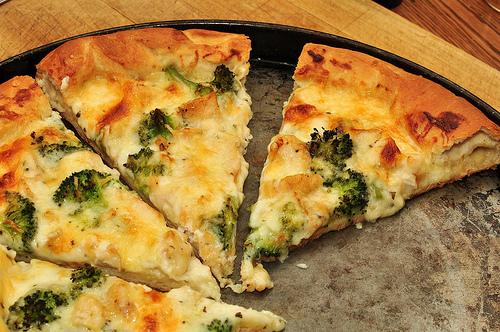Identify the material of the table and its color. The table is made of wood and is brown in color. Count the number of broccoli toppings on the pizza slices. There are 12 broccoli toppings on the pizza slices. What kind of topping can be seen on the pizza slices? Green broccoli can be seen as a topping on the pizza slices. How many pieces of pizza are there in the image and where are they placed? There are four pieces of pizza placed on a plate. Briefly describe the arrangement of objects in the image. A pizza with broccoli toppings is on a plate, the tray is on a wooden board on a brown wooden table, and there are some slices separated on a pan. What is the shape of the empty space between the pizzas? The space in between the pizzas is rectangular. What is the color of the cheese on the pizza? The cheese on the pizza is white in color. Describe the interaction between the wooden board and the tray. The tray is placed on the wooden board. Mention two colors you can see for different objects in the image. Green for the broccoli and brown for the table. What is the main food item in the image and its shape? The main food item is pizza, which has triangle-shaped slices. Can you describe the arrangement of the pizza pieces in the plate? There are four pizza pieces arranged in a circle on the plate. How many broccoli toppings are on the pizza slices? There are various numbers of broccoli toppings on the pizza slices. How would you describe the space between the pizzas? There is a considerable empty space between the pizzas. Create a short story based on the image. Once upon a time, in a small Italian restaurant, a unique broccoli pizza was created. Four triangular slices of perfection, with a golden crust, and white cheese melting among the vibrant green broccoli. It was served on a grey tray that lay on a rustic wooden board, over the brown wooden table. This pizza became the talk of the town, as everyone wanted a taste of the delightful and unexpected combination. What is the crust's position on the pizza slices, and where is the edge of the crust located? The crust is on the outer part of the pizza slices, and the edge of the crust is at the wider end of the triangles. Is the wooden board on the table blue in color? This instruction is misleading because it says the wooden board is blue, whereas the image information describes the board as brown. Can you see a circular-shaped pizza slice? This instruction is misleading because the image information states that the pizza slices are triangle in shape, not circular. Is the broccoli on the pizza red in color? The instruction is misleading because the image information mentions that the broccoli is green in color, not red. Explain the layout of the objects in the image. A pizza with broccoli toppings is on a grey tray on a wooden board on a brown table. There are also slices of pizza on pans and a bread nearby. Is the table made of glass? This instruction is misleading because the image information states that the table is made of brown wood. How many pieces of pizza are on the table, and what is underneath the pizza? There are two pieces of pizza on the table, and the table is underneath the pizza. What is the shape of the pizza pieces, and what color is the cheese on them? The pizza pieces are triangular in shape, and the cheese is white in color. Create a poem about the pizza and its toppings. A pizza with a golden crust, Is the cheese on the pizza yellow in color? The instruction is misleading because the image information mentions that the cheese is white in color, not yellow. Can you identify the activity happening in the image? The activity in the image is placing broccoli toppings on pizza slices. What is the dominating color of the table and the bread? The table is brown in color, and the bread is also brown. Where is the side of the pizza located in the image? The side of the pizza is on the right side of the image. Identify the position of the wooden board in relation to the table and tray. The wooden board is on the table, and the tray is on the wooden board. Please describe the emotion displayed by the person in the image. There is no person in the image. Which item is grey in color and located near the pizza? Tray Are there six pieces of pizza in the image? This instruction is misleading because the image information mentions two pizza pieces, not six. What is the color of the broccoli and what is its shape? The broccoli is green in color and has an irregular shape. What are the main elements on the pizza in the photo? The main elements are the crust, cheese, and green toppings (broccoli) on the pizza. Which object is at the top-left corner of the image? Pizza in a tray 